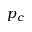<formula> <loc_0><loc_0><loc_500><loc_500>p _ { c }</formula> 